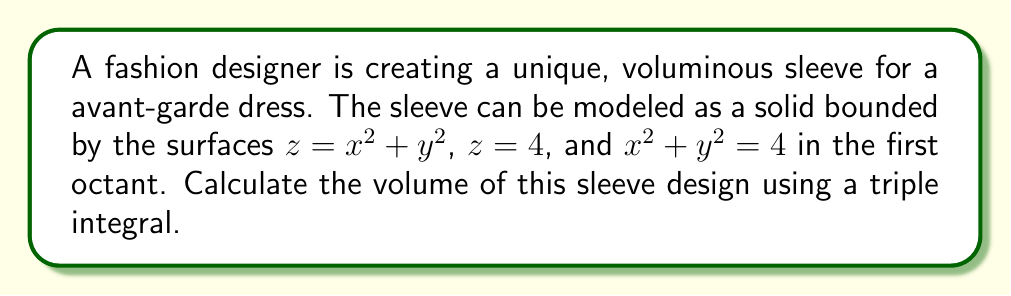Teach me how to tackle this problem. To find the volume of the sleeve design, we need to set up and evaluate a triple integral. Let's approach this step-by-step:

1) First, we need to determine the bounds of our integral. From the given equations:
   - The bottom surface is $z = x^2 + y^2$
   - The top surface is $z = 4$
   - The circular boundary is $x^2 + y^2 = 4$

2) Given that it's in the first octant, we can use cylindrical coordinates:
   $x = r\cos\theta$, $y = r\sin\theta$, $z = z$

3) The bounds in cylindrical coordinates will be:
   - $0 \leq r \leq 2$ (from $x^2 + y^2 = 4$)
   - $0 \leq \theta \leq \frac{\pi}{2}$ (first quadrant in xy-plane)
   - $r^2 \leq z \leq 4$ (from bottom to top surface)

4) The volume integral in cylindrical coordinates is:

   $$V = \int_0^{\frac{\pi}{2}} \int_0^2 \int_{r^2}^4 r \, dz \, dr \, d\theta$$

5) Let's evaluate the integral:

   $$\begin{align}
   V &= \int_0^{\frac{\pi}{2}} \int_0^2 \int_{r^2}^4 r \, dz \, dr \, d\theta \\
   &= \int_0^{\frac{\pi}{2}} \int_0^2 r(4-r^2) \, dr \, d\theta \\
   &= \int_0^{\frac{\pi}{2}} \left[2r^2 - \frac{r^4}{4}\right]_0^2 \, d\theta \\
   &= \int_0^{\frac{\pi}{2}} (8 - 4) \, d\theta \\
   &= 4 \int_0^{\frac{\pi}{2}} \, d\theta \\
   &= 4 \cdot \frac{\pi}{2} \\
   &= 2\pi
   \end{align}$$

Therefore, the volume of the sleeve design is $2\pi$ cubic units.
Answer: $2\pi$ cubic units 